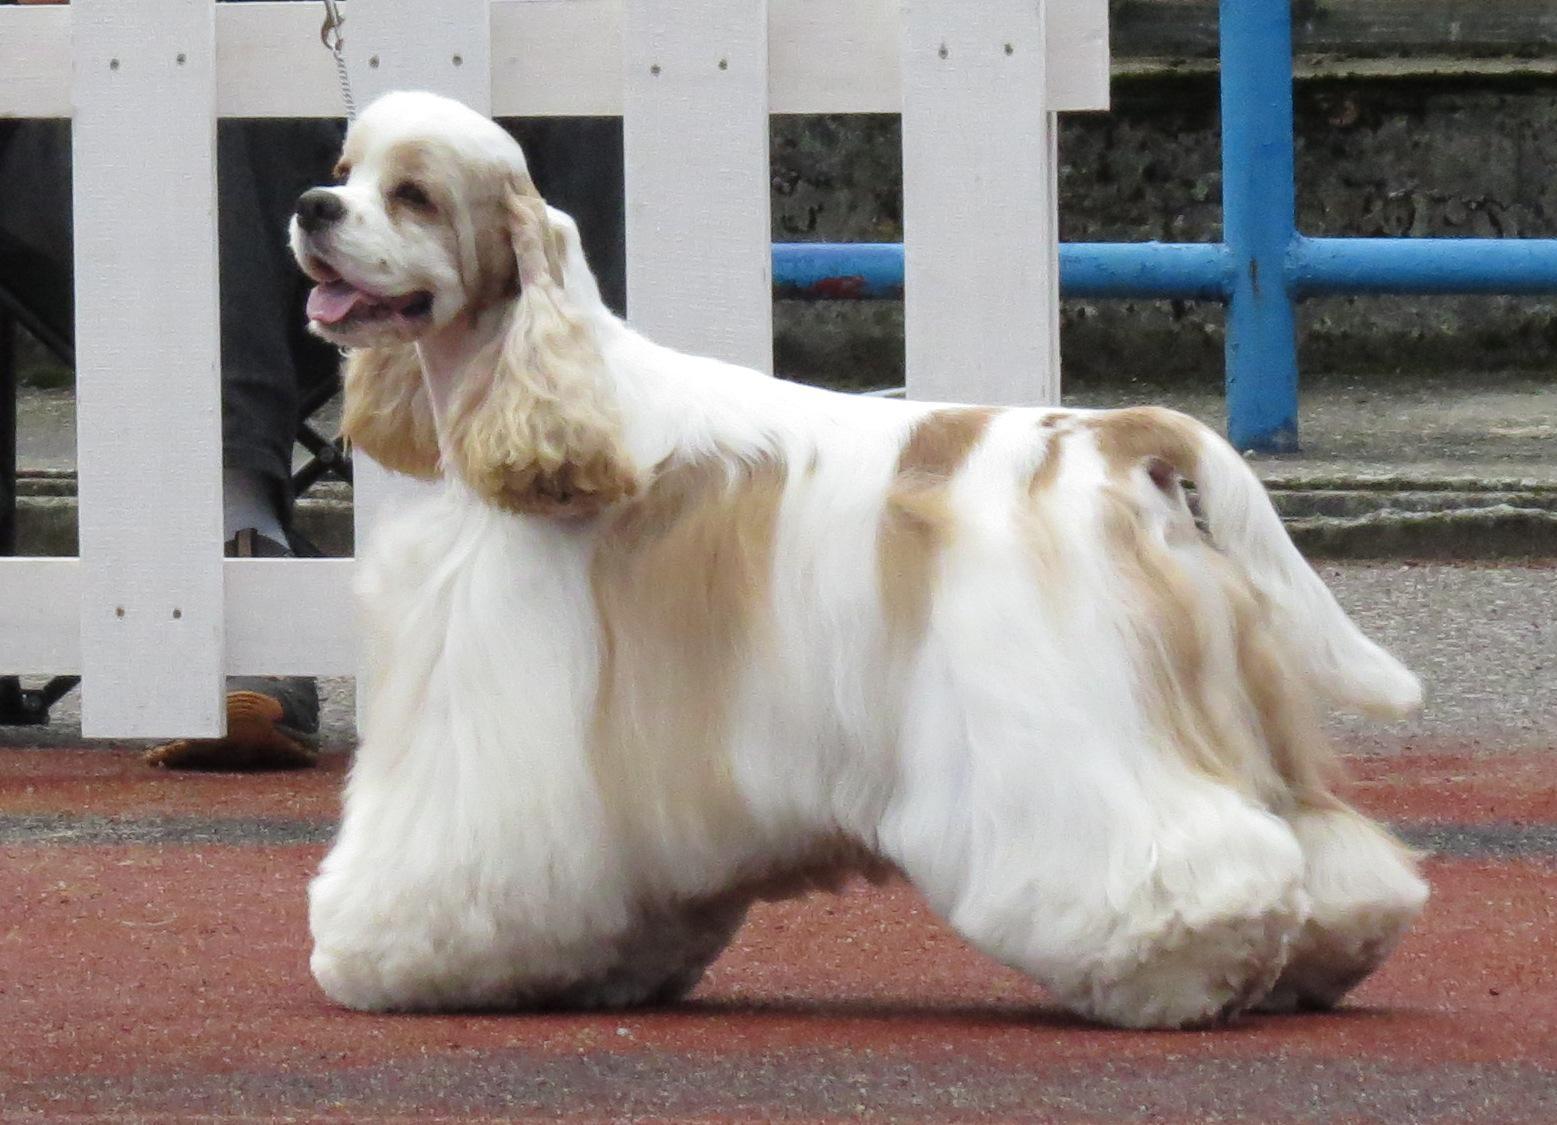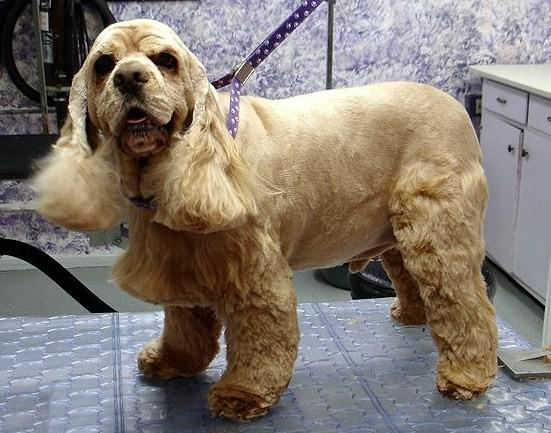The first image is the image on the left, the second image is the image on the right. Examine the images to the left and right. Is the description "There is more than one breed of dog in the image." accurate? Answer yes or no. No. The first image is the image on the left, the second image is the image on the right. Evaluate the accuracy of this statement regarding the images: "Left image shows a person standing behind a left-turned cocker spaniel, holding its chin and tail by a hand.". Is it true? Answer yes or no. No. 